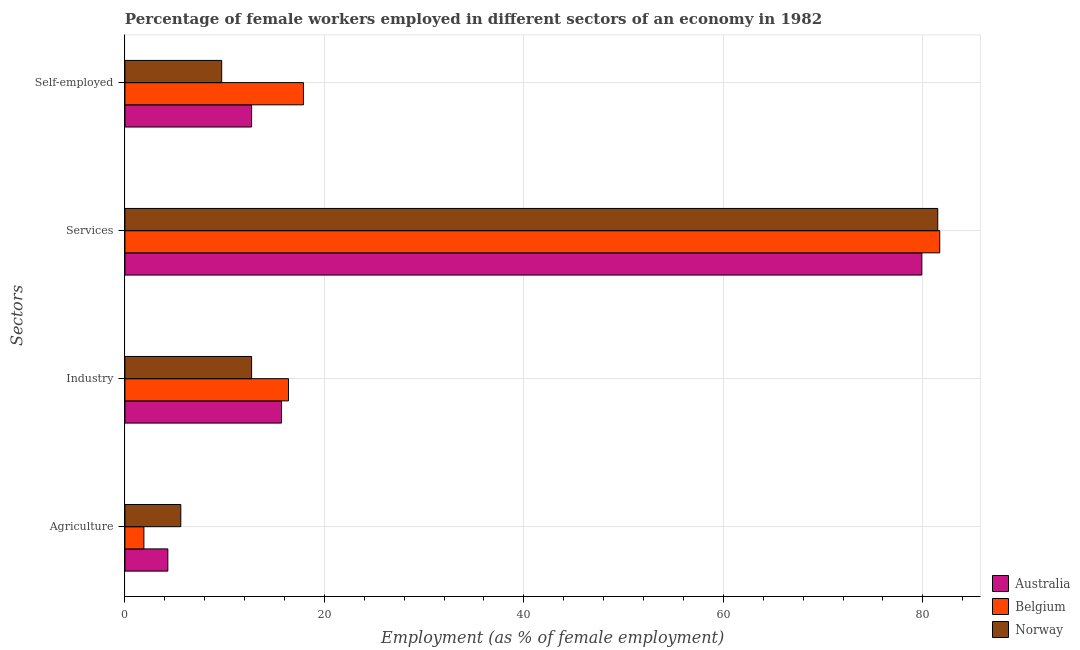How many different coloured bars are there?
Provide a short and direct response. 3. How many groups of bars are there?
Keep it short and to the point. 4. Are the number of bars per tick equal to the number of legend labels?
Your response must be concise. Yes. Are the number of bars on each tick of the Y-axis equal?
Your answer should be very brief. Yes. How many bars are there on the 3rd tick from the bottom?
Ensure brevity in your answer.  3. What is the label of the 4th group of bars from the top?
Provide a succinct answer. Agriculture. What is the percentage of female workers in agriculture in Norway?
Give a very brief answer. 5.6. Across all countries, what is the maximum percentage of female workers in industry?
Your answer should be very brief. 16.4. Across all countries, what is the minimum percentage of female workers in services?
Your response must be concise. 79.9. What is the total percentage of female workers in services in the graph?
Your response must be concise. 243.1. What is the difference between the percentage of female workers in agriculture in Norway and that in Australia?
Your response must be concise. 1.3. What is the difference between the percentage of self employed female workers in Norway and the percentage of female workers in industry in Belgium?
Ensure brevity in your answer.  -6.7. What is the average percentage of female workers in services per country?
Make the answer very short. 81.03. What is the difference between the percentage of female workers in agriculture and percentage of female workers in services in Belgium?
Provide a succinct answer. -79.8. What is the ratio of the percentage of female workers in services in Australia to that in Belgium?
Your response must be concise. 0.98. Is the percentage of self employed female workers in Australia less than that in Norway?
Keep it short and to the point. No. Is the difference between the percentage of female workers in industry in Australia and Belgium greater than the difference between the percentage of female workers in services in Australia and Belgium?
Provide a short and direct response. Yes. What is the difference between the highest and the second highest percentage of female workers in agriculture?
Offer a very short reply. 1.3. What is the difference between the highest and the lowest percentage of female workers in industry?
Offer a terse response. 3.7. In how many countries, is the percentage of female workers in industry greater than the average percentage of female workers in industry taken over all countries?
Offer a very short reply. 2. Is the sum of the percentage of female workers in services in Norway and Belgium greater than the maximum percentage of female workers in agriculture across all countries?
Provide a succinct answer. Yes. What does the 2nd bar from the top in Industry represents?
Provide a succinct answer. Belgium. What does the 2nd bar from the bottom in Self-employed represents?
Provide a short and direct response. Belgium. Are the values on the major ticks of X-axis written in scientific E-notation?
Offer a very short reply. No. Where does the legend appear in the graph?
Provide a succinct answer. Bottom right. How are the legend labels stacked?
Your response must be concise. Vertical. What is the title of the graph?
Your answer should be very brief. Percentage of female workers employed in different sectors of an economy in 1982. What is the label or title of the X-axis?
Give a very brief answer. Employment (as % of female employment). What is the label or title of the Y-axis?
Offer a very short reply. Sectors. What is the Employment (as % of female employment) in Australia in Agriculture?
Provide a short and direct response. 4.3. What is the Employment (as % of female employment) of Belgium in Agriculture?
Keep it short and to the point. 1.9. What is the Employment (as % of female employment) of Norway in Agriculture?
Your response must be concise. 5.6. What is the Employment (as % of female employment) in Australia in Industry?
Give a very brief answer. 15.7. What is the Employment (as % of female employment) in Belgium in Industry?
Your response must be concise. 16.4. What is the Employment (as % of female employment) of Norway in Industry?
Your answer should be very brief. 12.7. What is the Employment (as % of female employment) in Australia in Services?
Your answer should be very brief. 79.9. What is the Employment (as % of female employment) in Belgium in Services?
Your response must be concise. 81.7. What is the Employment (as % of female employment) of Norway in Services?
Provide a short and direct response. 81.5. What is the Employment (as % of female employment) of Australia in Self-employed?
Provide a succinct answer. 12.7. What is the Employment (as % of female employment) of Belgium in Self-employed?
Offer a very short reply. 17.9. What is the Employment (as % of female employment) in Norway in Self-employed?
Ensure brevity in your answer.  9.7. Across all Sectors, what is the maximum Employment (as % of female employment) in Australia?
Your answer should be compact. 79.9. Across all Sectors, what is the maximum Employment (as % of female employment) of Belgium?
Provide a short and direct response. 81.7. Across all Sectors, what is the maximum Employment (as % of female employment) in Norway?
Make the answer very short. 81.5. Across all Sectors, what is the minimum Employment (as % of female employment) in Australia?
Ensure brevity in your answer.  4.3. Across all Sectors, what is the minimum Employment (as % of female employment) of Belgium?
Provide a succinct answer. 1.9. Across all Sectors, what is the minimum Employment (as % of female employment) in Norway?
Your answer should be very brief. 5.6. What is the total Employment (as % of female employment) of Australia in the graph?
Provide a succinct answer. 112.6. What is the total Employment (as % of female employment) in Belgium in the graph?
Make the answer very short. 117.9. What is the total Employment (as % of female employment) of Norway in the graph?
Ensure brevity in your answer.  109.5. What is the difference between the Employment (as % of female employment) of Belgium in Agriculture and that in Industry?
Ensure brevity in your answer.  -14.5. What is the difference between the Employment (as % of female employment) in Norway in Agriculture and that in Industry?
Provide a short and direct response. -7.1. What is the difference between the Employment (as % of female employment) in Australia in Agriculture and that in Services?
Your response must be concise. -75.6. What is the difference between the Employment (as % of female employment) in Belgium in Agriculture and that in Services?
Your response must be concise. -79.8. What is the difference between the Employment (as % of female employment) of Norway in Agriculture and that in Services?
Your response must be concise. -75.9. What is the difference between the Employment (as % of female employment) of Norway in Agriculture and that in Self-employed?
Ensure brevity in your answer.  -4.1. What is the difference between the Employment (as % of female employment) of Australia in Industry and that in Services?
Make the answer very short. -64.2. What is the difference between the Employment (as % of female employment) of Belgium in Industry and that in Services?
Ensure brevity in your answer.  -65.3. What is the difference between the Employment (as % of female employment) of Norway in Industry and that in Services?
Your response must be concise. -68.8. What is the difference between the Employment (as % of female employment) in Belgium in Industry and that in Self-employed?
Offer a very short reply. -1.5. What is the difference between the Employment (as % of female employment) of Australia in Services and that in Self-employed?
Offer a very short reply. 67.2. What is the difference between the Employment (as % of female employment) of Belgium in Services and that in Self-employed?
Offer a terse response. 63.8. What is the difference between the Employment (as % of female employment) in Norway in Services and that in Self-employed?
Keep it short and to the point. 71.8. What is the difference between the Employment (as % of female employment) of Australia in Agriculture and the Employment (as % of female employment) of Belgium in Industry?
Provide a succinct answer. -12.1. What is the difference between the Employment (as % of female employment) of Australia in Agriculture and the Employment (as % of female employment) of Norway in Industry?
Provide a succinct answer. -8.4. What is the difference between the Employment (as % of female employment) in Belgium in Agriculture and the Employment (as % of female employment) in Norway in Industry?
Your answer should be very brief. -10.8. What is the difference between the Employment (as % of female employment) of Australia in Agriculture and the Employment (as % of female employment) of Belgium in Services?
Offer a very short reply. -77.4. What is the difference between the Employment (as % of female employment) in Australia in Agriculture and the Employment (as % of female employment) in Norway in Services?
Offer a very short reply. -77.2. What is the difference between the Employment (as % of female employment) in Belgium in Agriculture and the Employment (as % of female employment) in Norway in Services?
Provide a short and direct response. -79.6. What is the difference between the Employment (as % of female employment) in Australia in Agriculture and the Employment (as % of female employment) in Belgium in Self-employed?
Give a very brief answer. -13.6. What is the difference between the Employment (as % of female employment) of Australia in Industry and the Employment (as % of female employment) of Belgium in Services?
Make the answer very short. -66. What is the difference between the Employment (as % of female employment) of Australia in Industry and the Employment (as % of female employment) of Norway in Services?
Provide a short and direct response. -65.8. What is the difference between the Employment (as % of female employment) in Belgium in Industry and the Employment (as % of female employment) in Norway in Services?
Give a very brief answer. -65.1. What is the difference between the Employment (as % of female employment) of Australia in Industry and the Employment (as % of female employment) of Belgium in Self-employed?
Offer a terse response. -2.2. What is the difference between the Employment (as % of female employment) of Australia in Services and the Employment (as % of female employment) of Norway in Self-employed?
Provide a short and direct response. 70.2. What is the difference between the Employment (as % of female employment) of Belgium in Services and the Employment (as % of female employment) of Norway in Self-employed?
Offer a terse response. 72. What is the average Employment (as % of female employment) of Australia per Sectors?
Give a very brief answer. 28.15. What is the average Employment (as % of female employment) of Belgium per Sectors?
Your response must be concise. 29.48. What is the average Employment (as % of female employment) of Norway per Sectors?
Your response must be concise. 27.38. What is the difference between the Employment (as % of female employment) of Belgium and Employment (as % of female employment) of Norway in Agriculture?
Your answer should be compact. -3.7. What is the difference between the Employment (as % of female employment) of Australia and Employment (as % of female employment) of Belgium in Industry?
Your answer should be compact. -0.7. What is the difference between the Employment (as % of female employment) of Australia and Employment (as % of female employment) of Norway in Industry?
Provide a short and direct response. 3. What is the difference between the Employment (as % of female employment) in Australia and Employment (as % of female employment) in Norway in Services?
Your response must be concise. -1.6. What is the difference between the Employment (as % of female employment) in Australia and Employment (as % of female employment) in Norway in Self-employed?
Your answer should be compact. 3. What is the difference between the Employment (as % of female employment) of Belgium and Employment (as % of female employment) of Norway in Self-employed?
Keep it short and to the point. 8.2. What is the ratio of the Employment (as % of female employment) of Australia in Agriculture to that in Industry?
Offer a very short reply. 0.27. What is the ratio of the Employment (as % of female employment) of Belgium in Agriculture to that in Industry?
Ensure brevity in your answer.  0.12. What is the ratio of the Employment (as % of female employment) in Norway in Agriculture to that in Industry?
Keep it short and to the point. 0.44. What is the ratio of the Employment (as % of female employment) in Australia in Agriculture to that in Services?
Offer a very short reply. 0.05. What is the ratio of the Employment (as % of female employment) of Belgium in Agriculture to that in Services?
Keep it short and to the point. 0.02. What is the ratio of the Employment (as % of female employment) of Norway in Agriculture to that in Services?
Make the answer very short. 0.07. What is the ratio of the Employment (as % of female employment) of Australia in Agriculture to that in Self-employed?
Keep it short and to the point. 0.34. What is the ratio of the Employment (as % of female employment) in Belgium in Agriculture to that in Self-employed?
Keep it short and to the point. 0.11. What is the ratio of the Employment (as % of female employment) in Norway in Agriculture to that in Self-employed?
Provide a short and direct response. 0.58. What is the ratio of the Employment (as % of female employment) of Australia in Industry to that in Services?
Keep it short and to the point. 0.2. What is the ratio of the Employment (as % of female employment) in Belgium in Industry to that in Services?
Ensure brevity in your answer.  0.2. What is the ratio of the Employment (as % of female employment) of Norway in Industry to that in Services?
Offer a very short reply. 0.16. What is the ratio of the Employment (as % of female employment) of Australia in Industry to that in Self-employed?
Offer a terse response. 1.24. What is the ratio of the Employment (as % of female employment) in Belgium in Industry to that in Self-employed?
Offer a terse response. 0.92. What is the ratio of the Employment (as % of female employment) in Norway in Industry to that in Self-employed?
Provide a succinct answer. 1.31. What is the ratio of the Employment (as % of female employment) of Australia in Services to that in Self-employed?
Your answer should be very brief. 6.29. What is the ratio of the Employment (as % of female employment) in Belgium in Services to that in Self-employed?
Your answer should be compact. 4.56. What is the ratio of the Employment (as % of female employment) of Norway in Services to that in Self-employed?
Provide a short and direct response. 8.4. What is the difference between the highest and the second highest Employment (as % of female employment) of Australia?
Provide a short and direct response. 64.2. What is the difference between the highest and the second highest Employment (as % of female employment) of Belgium?
Your answer should be very brief. 63.8. What is the difference between the highest and the second highest Employment (as % of female employment) of Norway?
Your response must be concise. 68.8. What is the difference between the highest and the lowest Employment (as % of female employment) in Australia?
Offer a terse response. 75.6. What is the difference between the highest and the lowest Employment (as % of female employment) in Belgium?
Provide a succinct answer. 79.8. What is the difference between the highest and the lowest Employment (as % of female employment) in Norway?
Provide a succinct answer. 75.9. 